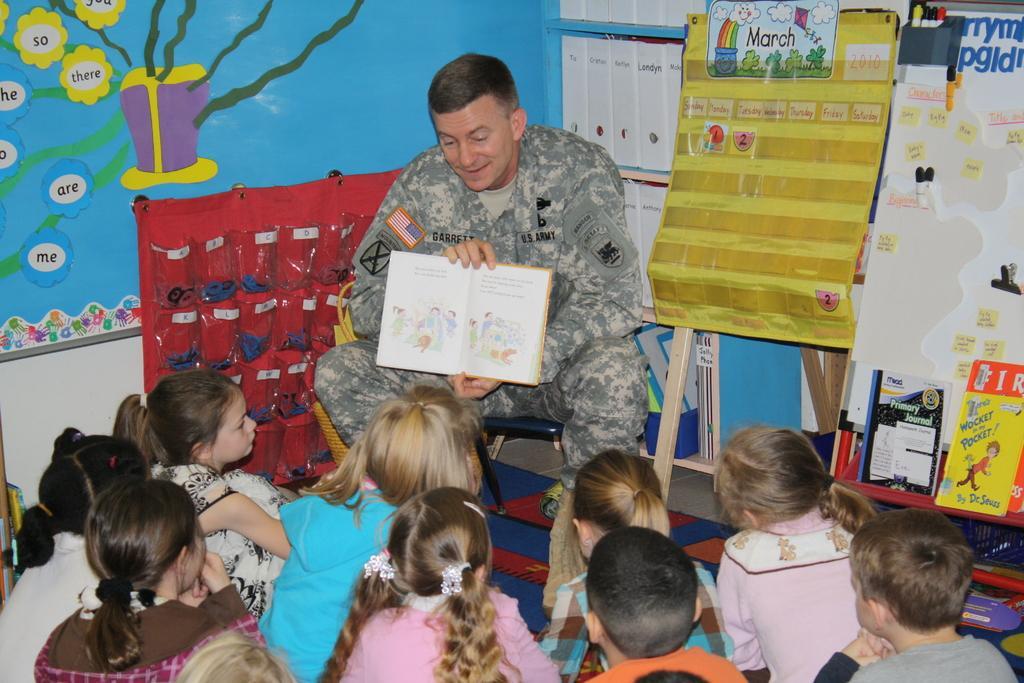How would you summarize this image in a sentence or two? In this image in the center there is one man who is standing and he is holding a book, and at the bottom there are a group of children who are sitting and in the background there are some boards. And on the boards there is some text and also there are some paintings. 